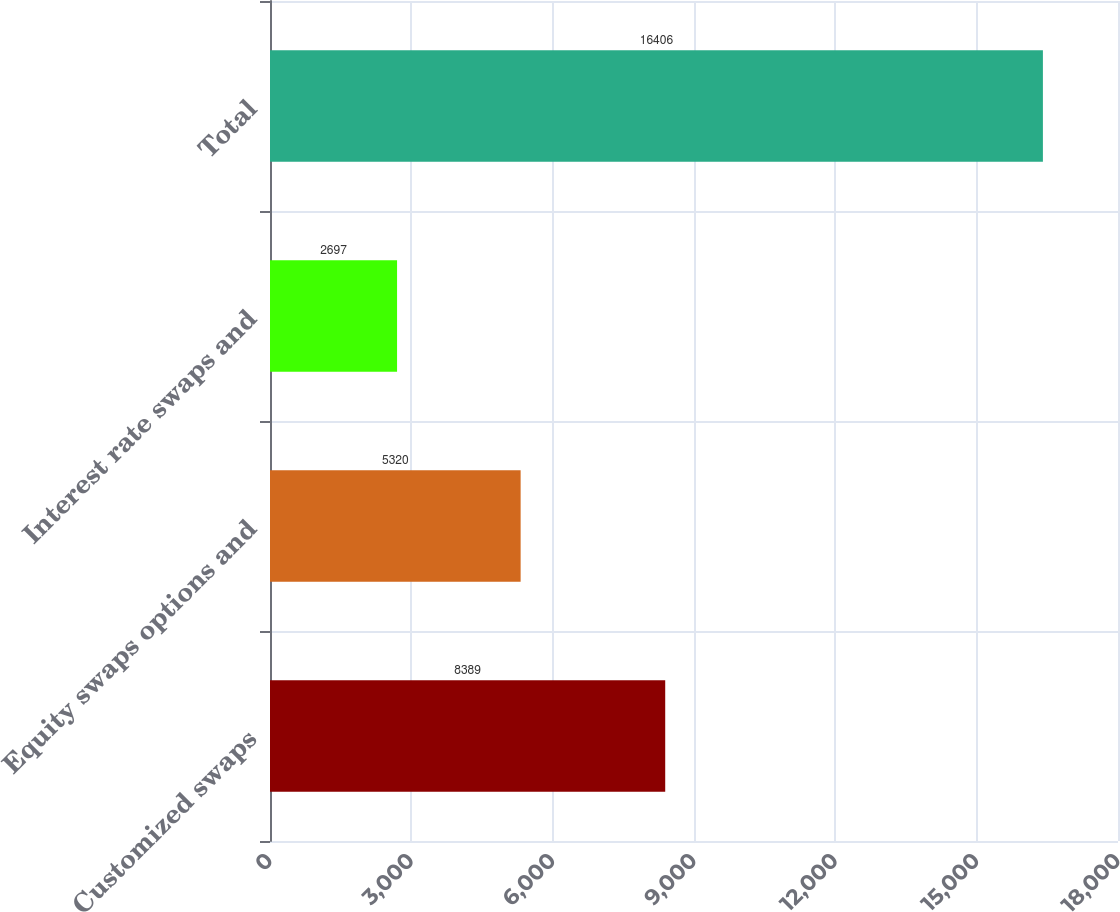<chart> <loc_0><loc_0><loc_500><loc_500><bar_chart><fcel>Customized swaps<fcel>Equity swaps options and<fcel>Interest rate swaps and<fcel>Total<nl><fcel>8389<fcel>5320<fcel>2697<fcel>16406<nl></chart> 